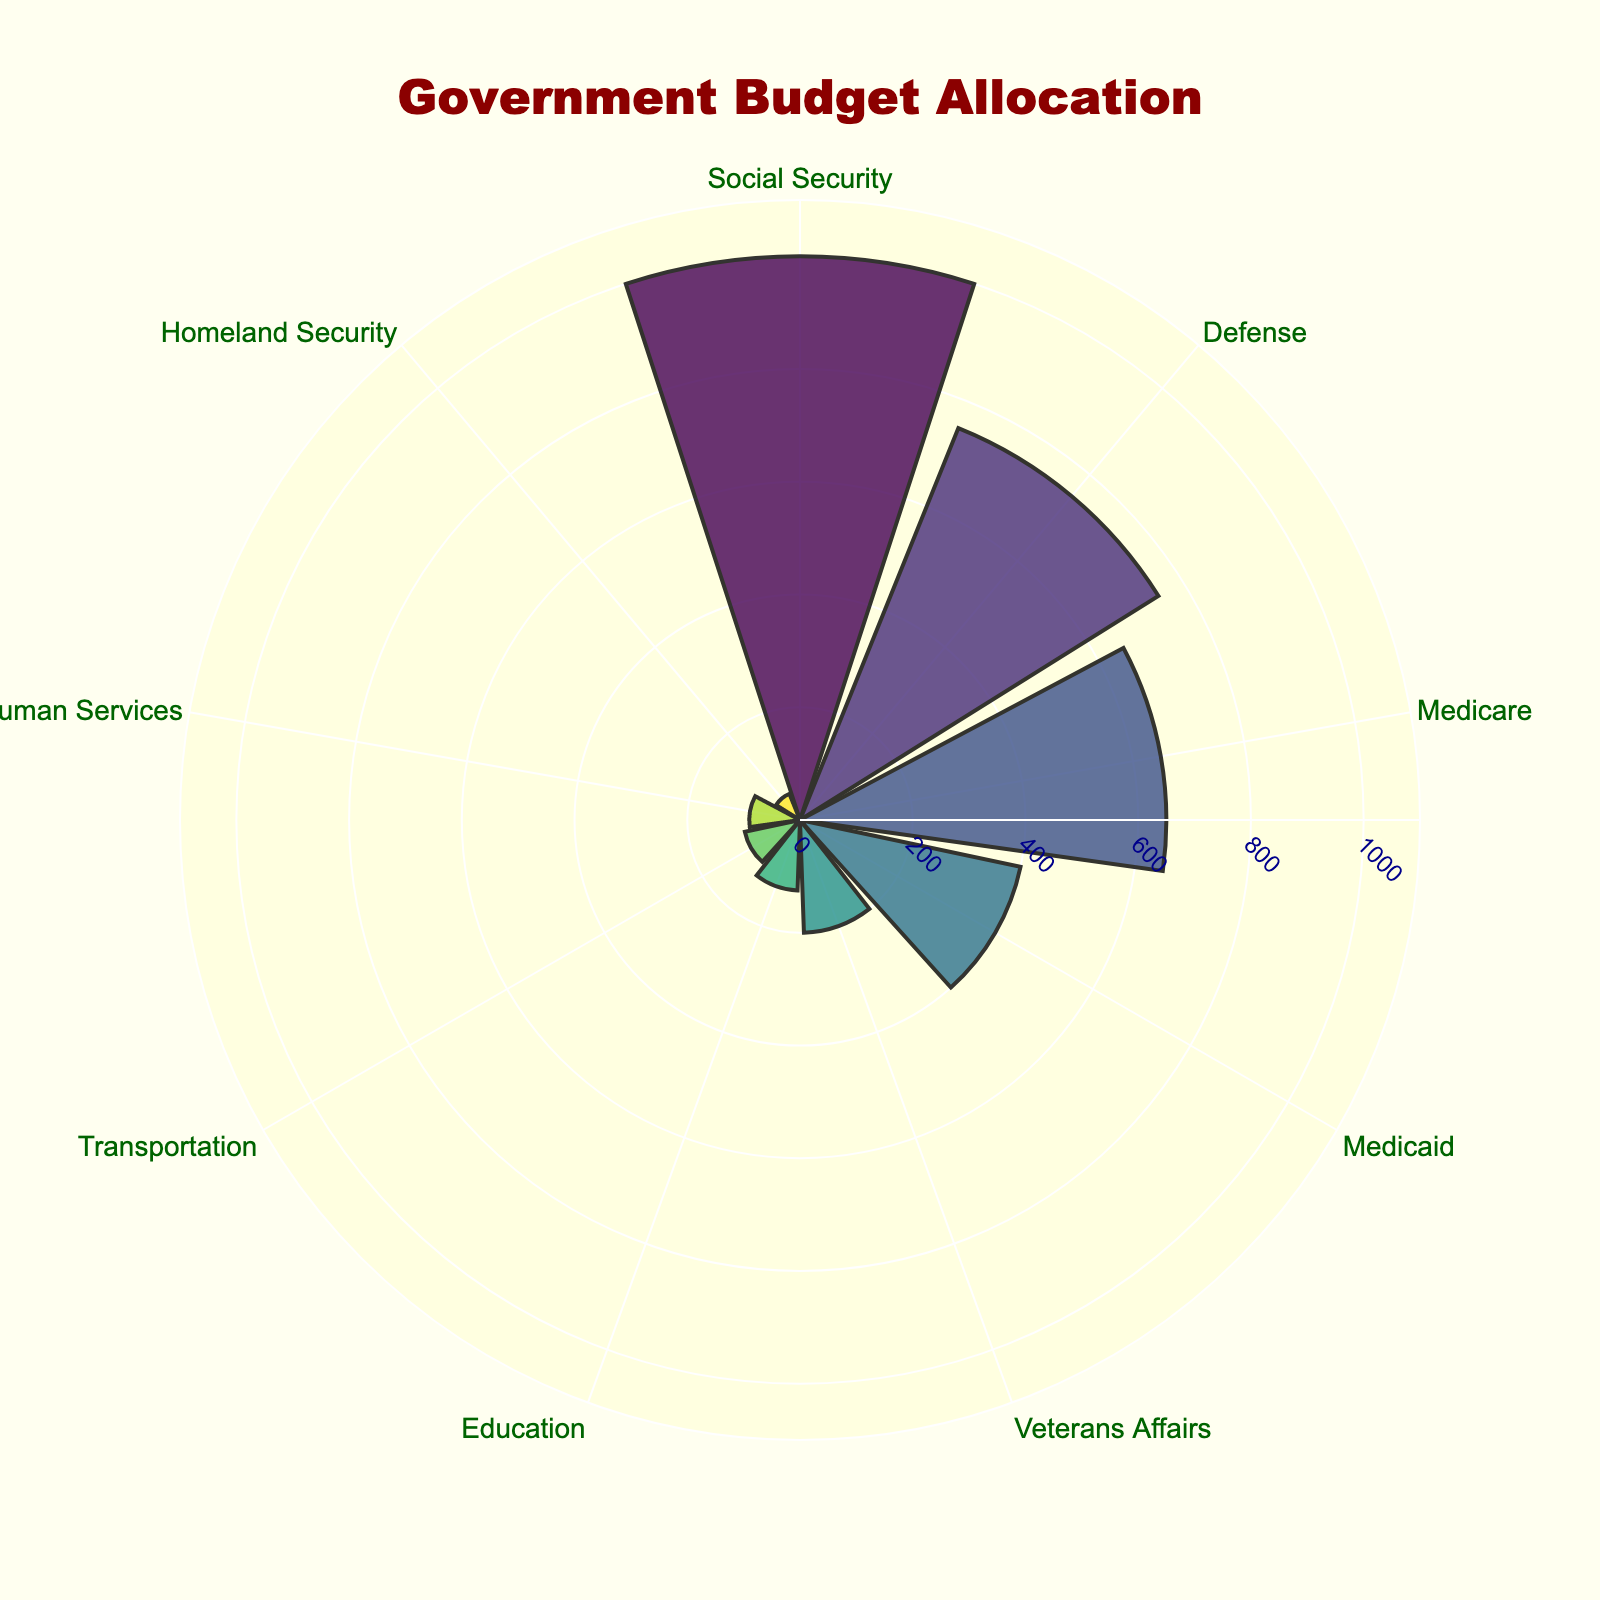What is the title of the chart? The title is located at the top center of the chart, displayed prominently in dark red color and larger font size.
Answer: Government Budget Allocation Which category has the largest allocation in the budget? The category with the largest allocation is positioned at the top when sorted by values. In this chart, it is Social Security.
Answer: Social Security What are the two smallest budget allocations in the chart? Identify the categories with the smallest radial distances from the center, which represent the smallest values. Homeland Security and Health and Human Services are the smallest.
Answer: Homeland Security, Health and Human Services How does the allocation for Defense compare to Medicaid? Compare the length of the radial bars for Defense and Medicaid. The radial bar for Defense is longer than that for Medicaid, indicating a higher value.
Answer: Defense is larger than Medicaid Which three categories receive more budget allocations than Veterans Affairs? Look for the categories with radial bars longer than the Veterans Affairs bar. Social Security, Defense, and Medicare have higher allocations.
Answer: Social Security, Defense, Medicare What is the total budget allocation for Medicare, Medicaid, and Education? Add the values for Medicare (650), Medicaid (400), and Education (125). 650 + 400 + 125 = 1175.
Answer: 1175 What is the color scheme used for the bars in the chart? The bars use a viridis color scale, which ranges from purple to yellow. The colors are distinguished by different shades based on values.
Answer: Viridis color scale What is the background color of the polar chart? Observe the area inside the polar chart; it has a light yellow background for better visibility of the bars.
Answer: Light yellow How does the radial distance for Transportation compare to the average of Education and Health and Human Services? Calculate the average value for Education (125) and Health and Human Services (90), resulting in (125 + 90)/2 = 107.5. The radial distance for Transportation is 100, which is less than 107.5.
Answer: Less than the average Which categories have visible tick marks displaced at 45-degree angles on the radial axis? Notice that the tick marks, found at regular intervals on the radial axis, are displayed for all the categories, ensuring readability at 45-degree angles.
Answer: All categories What is the range of values displayed on the radial axis? The radial axis extends slightly beyond the maximum value to accommodate all data points. Given the largest value is 1000 (Social Security), and the range is set to 1.1 times the maximum, it is 0 to 1100.
Answer: 0 to 1100 